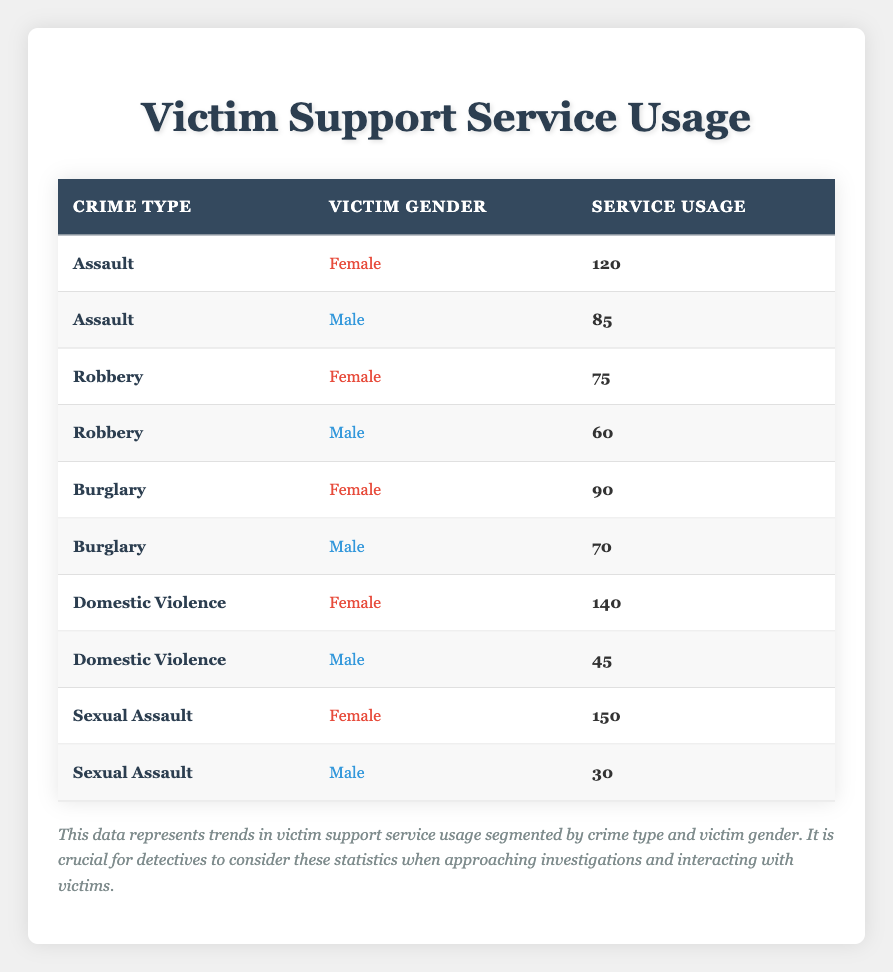What is the total service usage for female victims across all crime types? To find the total service usage for female victims, I must sum the values of the "service_usage" column for all rows where "victim_gender" is "Female." The values are: 120 (Assault) + 75 (Robbery) + 90 (Burglary) + 140 (Domestic Violence) + 150 (Sexual Assault) = 575.
Answer: 575 How many male victims used support services for Domestic Violence? The table lists a row for Domestic Violence with "victim_gender" as "Male." Referring to that row, the service usage is 45.
Answer: 45 Which crime type had the highest service usage for male victims? I need to analyze the "service_usage" values for all male victims and identify the highest one. The values are: 85 (Assault), 60 (Robbery), 70 (Burglary), 45 (Domestic Violence), and 30 (Sexual Assault). The highest value is 85 for Assault.
Answer: Assault Is it true that more female victims than male victims used services for Sexual Assault? Comparing the service usage for Sexual Assault: for females, it's 150, and for males, it's 30. Since 150 is greater than 30, the statement is true.
Answer: Yes What is the average service usage for male victims across all crime types? To calculate the average, I sum the service usage for male victims: 85 (Assault) + 60 (Robbery) + 70 (Burglary) + 45 (Domestic Violence) + 30 (Sexual Assault) = 290. There are 5 entries, so the average is 290/5 = 58.
Answer: 58 What is the difference in service usage between female and male victims for Burglary? The service usage for female victims of Burglary is 90, and for male victims, it is 70. The difference is 90 - 70 = 20.
Answer: 20 How many total service usages were recorded for crimes involving male victims? I will sum the service usage for all male victim entries, which are: 85 (Assault) + 60 (Robbery) + 70 (Burglary) + 45 (Domestic Violence) + 30 (Sexual Assault) = 290.
Answer: 290 Among all crime types, which has the largest gap in service usage between female and male victims? To find the largest gap, I evaluate the difference for each crime type: Assault (120 - 85 = 35), Robbery (75 - 60 = 15), Burglary (90 - 70 = 20), Domestic Violence (140 - 45 = 95), and Sexual Assault (150 - 30 = 120). The largest gap is 120 for Sexual Assault.
Answer: Sexual Assault 